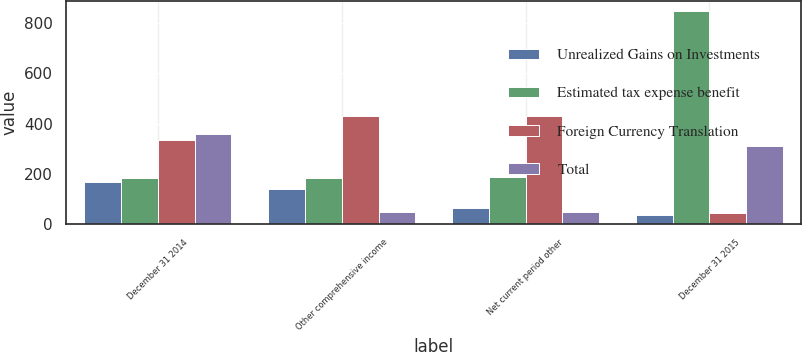Convert chart to OTSL. <chart><loc_0><loc_0><loc_500><loc_500><stacked_bar_chart><ecel><fcel>December 31 2014<fcel>Other comprehensive income<fcel>Net current period other<fcel>December 31 2015<nl><fcel>Unrealized Gains on Investments<fcel>168<fcel>139<fcel>65<fcel>36<nl><fcel>Estimated tax expense benefit<fcel>186<fcel>186<fcel>187<fcel>845<nl><fcel>Foreign Currency Translation<fcel>334<fcel>431<fcel>431<fcel>45<nl><fcel>Total<fcel>360<fcel>50<fcel>50<fcel>310<nl></chart> 